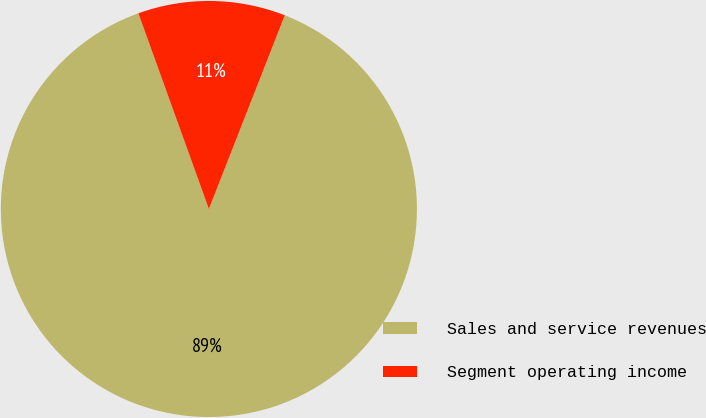Convert chart to OTSL. <chart><loc_0><loc_0><loc_500><loc_500><pie_chart><fcel>Sales and service revenues<fcel>Segment operating income<nl><fcel>88.55%<fcel>11.45%<nl></chart> 